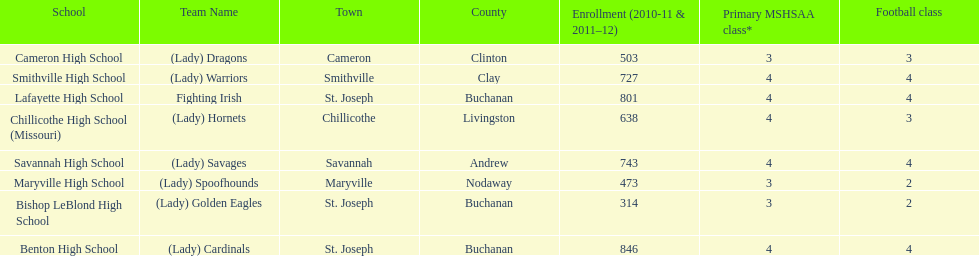Parse the table in full. {'header': ['School', 'Team Name', 'Town', 'County', 'Enrollment (2010-11 & 2011–12)', 'Primary MSHSAA class*', 'Football class'], 'rows': [['Cameron High School', '(Lady) Dragons', 'Cameron', 'Clinton', '503', '3', '3'], ['Smithville High School', '(Lady) Warriors', 'Smithville', 'Clay', '727', '4', '4'], ['Lafayette High School', 'Fighting Irish', 'St. Joseph', 'Buchanan', '801', '4', '4'], ['Chillicothe High School (Missouri)', '(Lady) Hornets', 'Chillicothe', 'Livingston', '638', '4', '3'], ['Savannah High School', '(Lady) Savages', 'Savannah', 'Andrew', '743', '4', '4'], ['Maryville High School', '(Lady) Spoofhounds', 'Maryville', 'Nodaway', '473', '3', '2'], ['Bishop LeBlond High School', '(Lady) Golden Eagles', 'St. Joseph', 'Buchanan', '314', '3', '2'], ['Benton High School', '(Lady) Cardinals', 'St. Joseph', 'Buchanan', '846', '4', '4']]} Which school has the largest enrollment? Benton High School. 